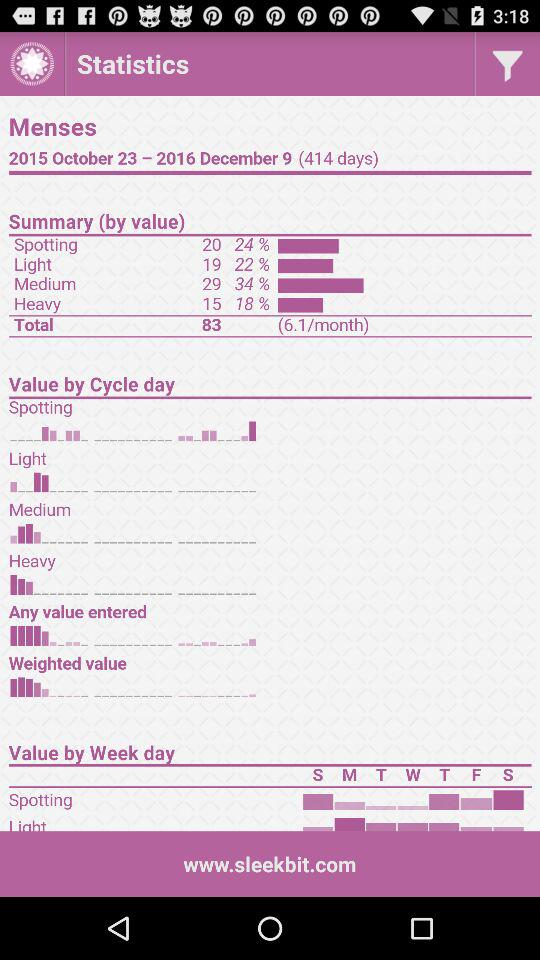What is the total mentioned in "Summary (by value)"? The total mentioned in "Summary (by value)" is 83. 